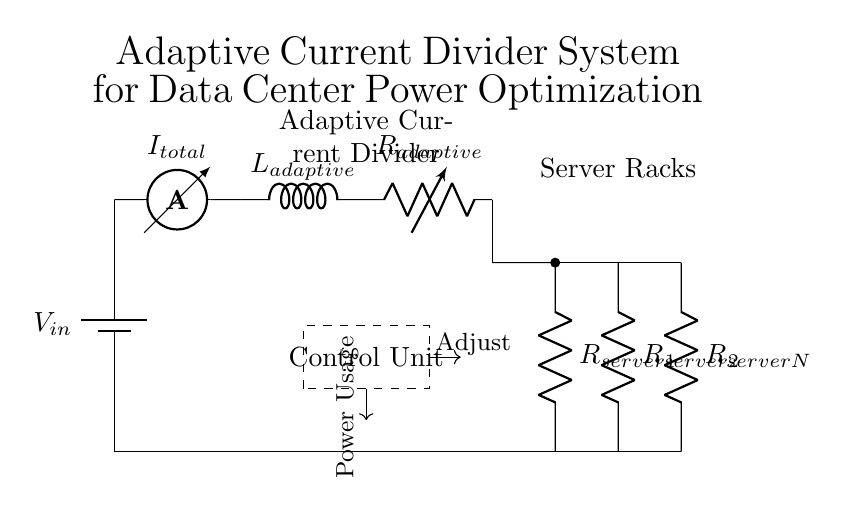What is the input voltage in the circuit? The input voltage is labeled as V_in in the circuit, which represents the supply voltage for the entire system.
Answer: V_in What is the role of the control unit in this circuit? The control unit manages the adaptive current divider by monitoring power usage and sending signals to adjust the resistive element in the circuit, optimizing power consumption based on the data received.
Answer: Adjusts current flow How many server racks are indicated in the circuit? The circuit shows three server racks branching from the adaptive current divider, represented by R_server1, R_server2, and R_serverN.
Answer: Three What components are used in the adaptive current divider? The adaptive current divider consists of an inductor (L_adaptive) and a variable resistor (R_adaptive), which work together to manage and split the current between the server racks.
Answer: Inductor and variable resistor How does the current from the main supply distribute among the server racks? The total current from the main supply is divided among the server racks based on the resistance offered by each rack. The adaptive current divider adjusts the resistance to optimize power consumption, leading to an effective division of current according to the varying load conditions.
Answer: Based on resistance 